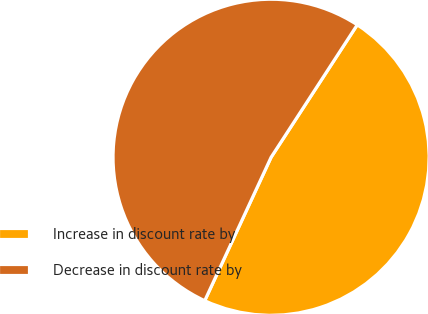<chart> <loc_0><loc_0><loc_500><loc_500><pie_chart><fcel>Increase in discount rate by<fcel>Decrease in discount rate by<nl><fcel>47.72%<fcel>52.28%<nl></chart> 